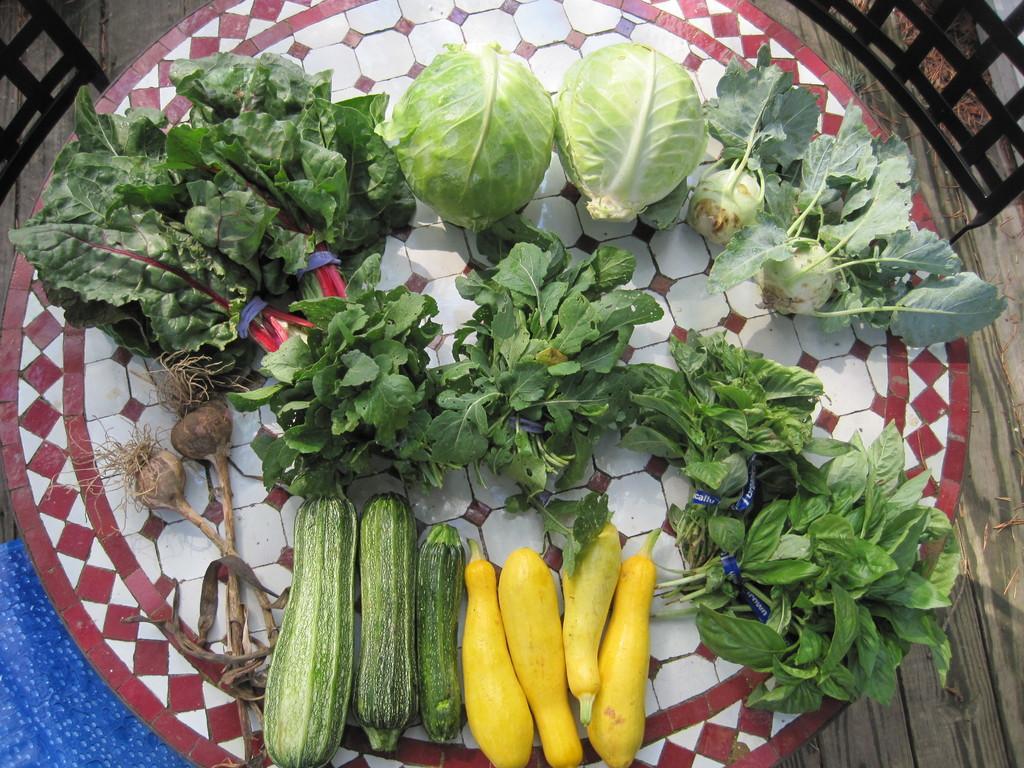Please provide a concise description of this image. In this picture we can see vegetables on the table. Under the table, there is a wooden floor. In the top left and right corners of the image, there are chairs. In the bottom left corner of the image, there is a blue object. 